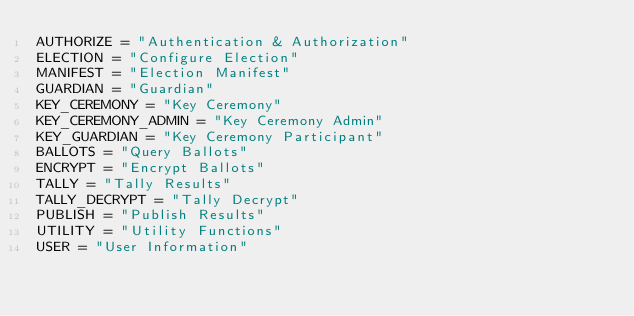<code> <loc_0><loc_0><loc_500><loc_500><_Python_>AUTHORIZE = "Authentication & Authorization"
ELECTION = "Configure Election"
MANIFEST = "Election Manifest"
GUARDIAN = "Guardian"
KEY_CEREMONY = "Key Ceremony"
KEY_CEREMONY_ADMIN = "Key Ceremony Admin"
KEY_GUARDIAN = "Key Ceremony Participant"
BALLOTS = "Query Ballots"
ENCRYPT = "Encrypt Ballots"
TALLY = "Tally Results"
TALLY_DECRYPT = "Tally Decrypt"
PUBLISH = "Publish Results"
UTILITY = "Utility Functions"
USER = "User Information"
</code> 